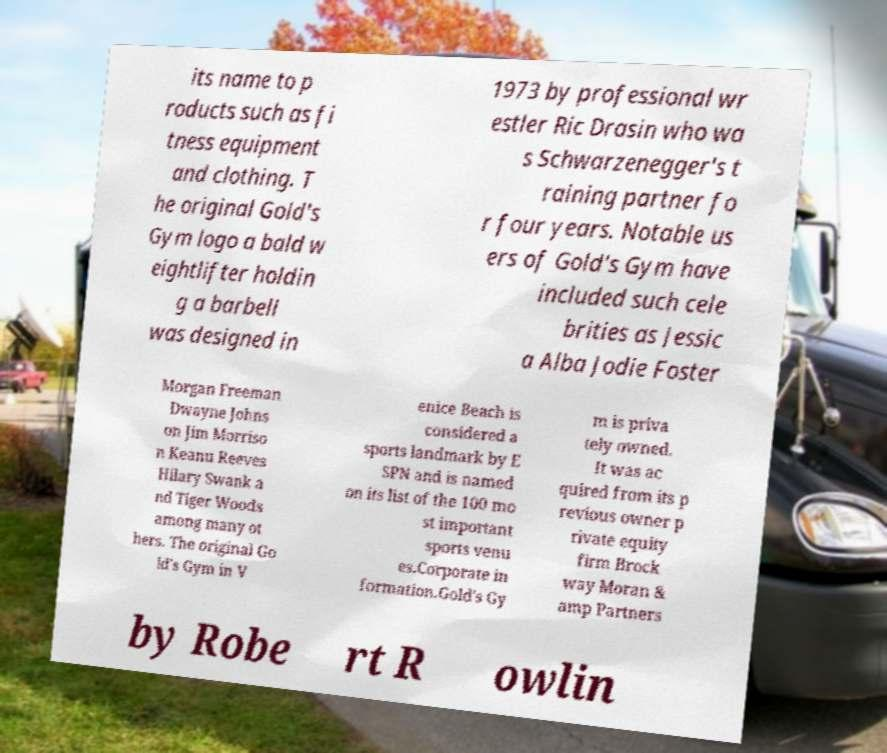There's text embedded in this image that I need extracted. Can you transcribe it verbatim? its name to p roducts such as fi tness equipment and clothing. T he original Gold's Gym logo a bald w eightlifter holdin g a barbell was designed in 1973 by professional wr estler Ric Drasin who wa s Schwarzenegger's t raining partner fo r four years. Notable us ers of Gold's Gym have included such cele brities as Jessic a Alba Jodie Foster Morgan Freeman Dwayne Johns on Jim Morriso n Keanu Reeves Hilary Swank a nd Tiger Woods among many ot hers. The original Go ld's Gym in V enice Beach is considered a sports landmark by E SPN and is named on its list of the 100 mo st important sports venu es.Corporate in formation.Gold's Gy m is priva tely owned. It was ac quired from its p revious owner p rivate equity firm Brock way Moran & amp Partners by Robe rt R owlin 